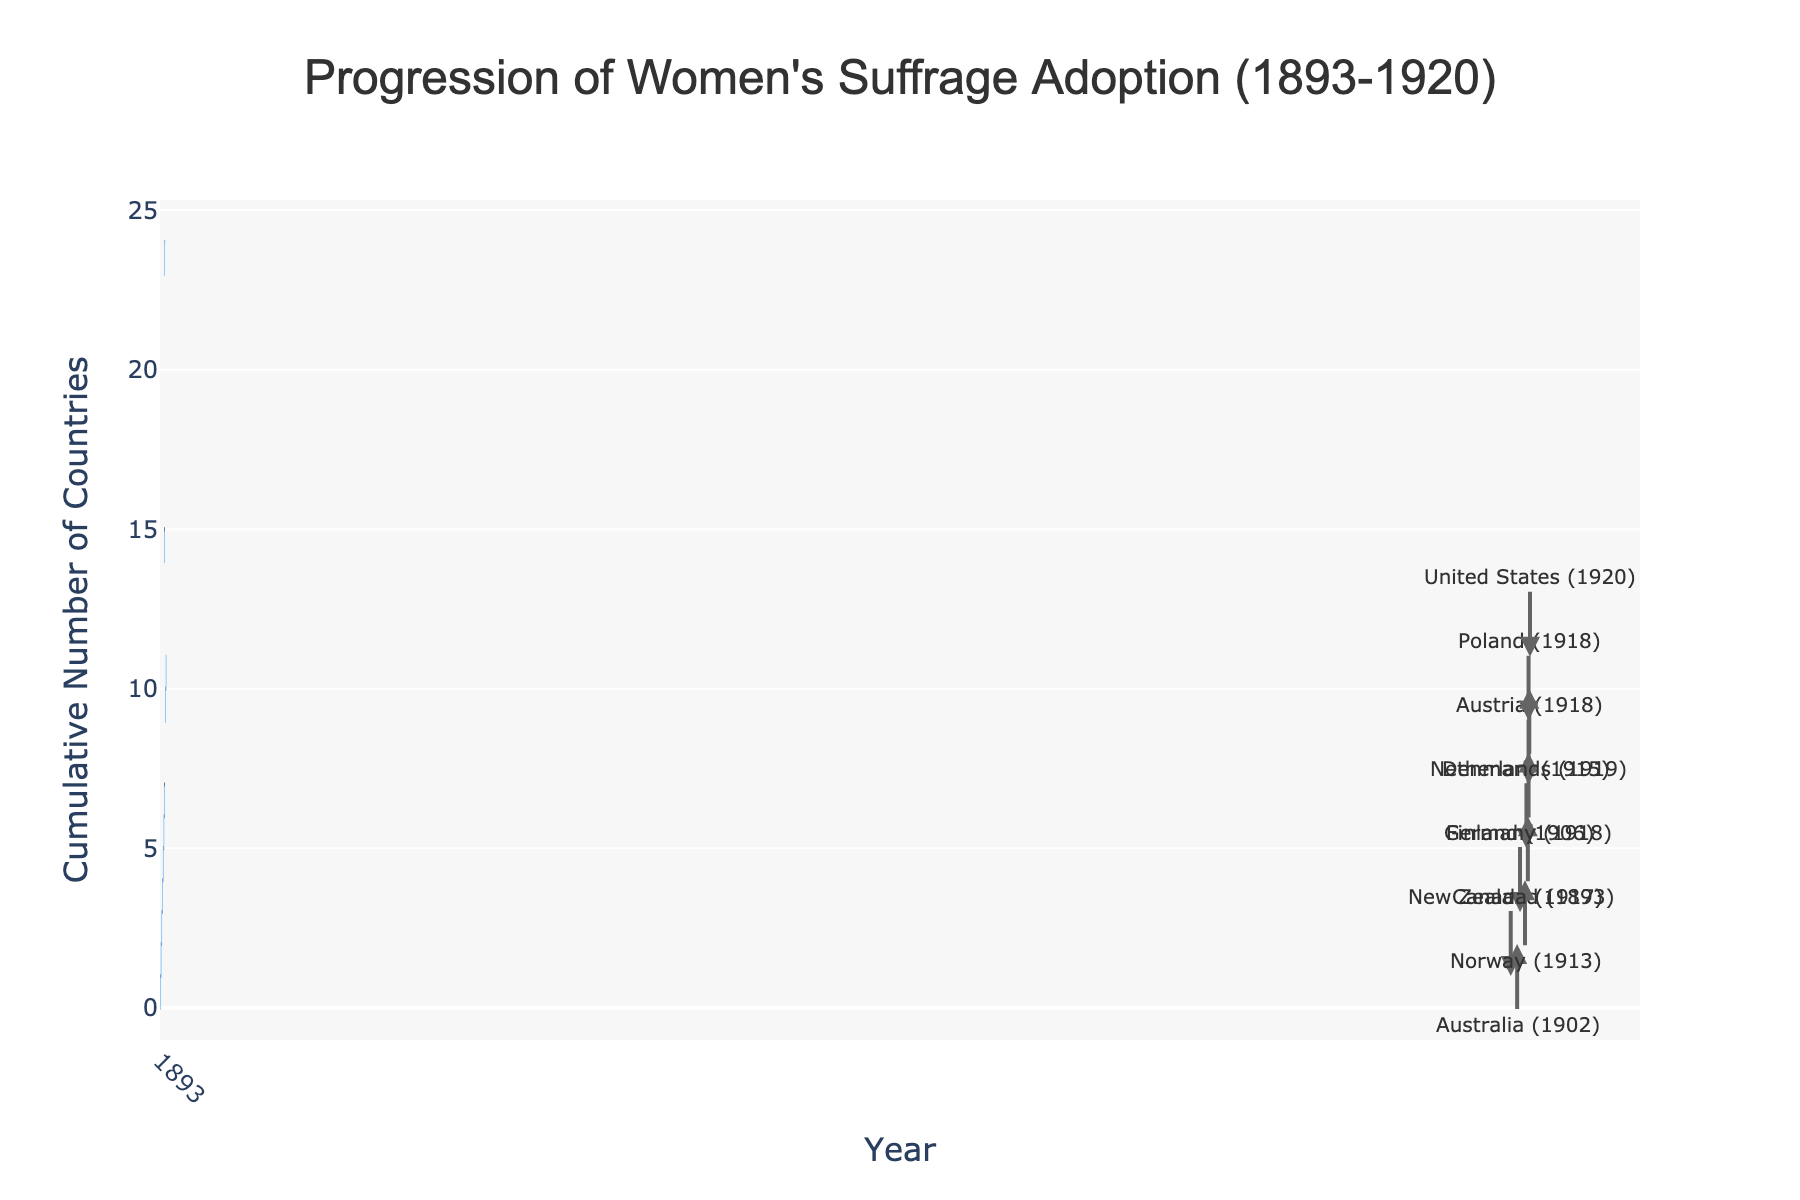How many countries had adopted women's suffrage by 1920? To find this, look at the total number of countries on the y-axis by the year 1920. The last data point at 1920 shows the cumulative number of countries.
Answer: 11 Which country was the first to adopt women's suffrage according to the chart? Examine the country name associated with the earliest year on the x-axis. The earliest year is 1893, and the country name shown is New Zealand.
Answer: New Zealand What is the title of the figure? The title is usually placed at the top center of the figure. Look for a text that summarizes the overall content shown in the plot.
Answer: Progression of Women's Suffrage Adoption (1893-1920) How many countries adopted women's suffrage in 1918? Check the number of data points listed for the year 1918. There are three separate steps in this year indicating three different countries: Austria, Germany, and Poland.
Answer: 3 Which country adopted women's suffrage just before the United States? Trace the chronological order of the countries adopting women’s suffrage by their placement in the plot, stopping at the country immediately preceding the United States in 1920. The country listed just before 1920 is the Netherlands in 1919.
Answer: Netherlands By how many countries did the adoption increase between 1917 and 1918? Check the cumulative number of countries for both years and find the difference. In 1917, the cumulative count is 6; in 1918, it is 9. The difference is 9 - 6 = 3.
Answer: 3 What years saw an increase in the number of countries adopting women's suffrage? Identify all the unique years along the x-axis, as each represents an increase in the number of countries. These years are 1893, 1902, 1906, 1913, 1915, 1917, 1918, 1919, and 1920.
Answer: 1893, 1902, 1906, 1913, 1915, 1917, 1918, 1919, 1920 What is the significance of the color changes in the bars? The color variations often represent different types of changes in waterfall charts. In this case, look for legend or accompanying text describing what the colors signify. The bars use different colors to mark each incremental year and did not exhibit any decreasing values; hence, they likely reflect the positive progression.
Answer: To indicate progression What was the total increase in the number of countries from 1915 to 1918? Identify the cumulative numbers for the years 1915 and 1918 and calculate the difference. In 1915 the count is 5, and in 1918 it is 9. The total increase is 9 - 5 = 4.
Answer: 4 